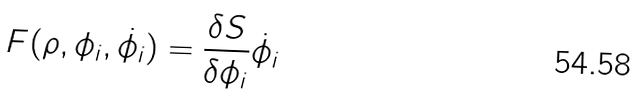<formula> <loc_0><loc_0><loc_500><loc_500>F ( \rho , \phi _ { i } , \dot { \phi _ { i } } ) = { \frac { \delta S } { \delta \phi _ { i } } } \dot { \phi _ { i } }</formula> 